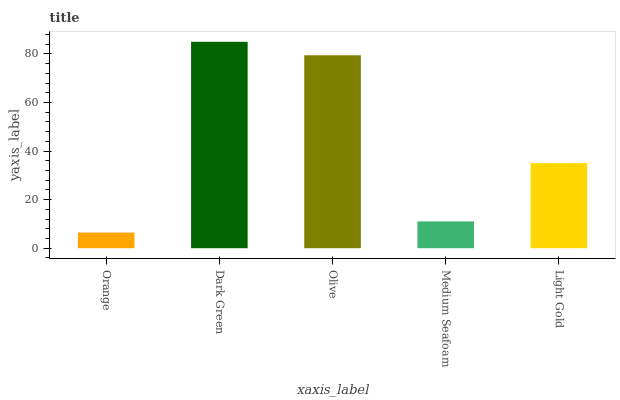Is Orange the minimum?
Answer yes or no. Yes. Is Dark Green the maximum?
Answer yes or no. Yes. Is Olive the minimum?
Answer yes or no. No. Is Olive the maximum?
Answer yes or no. No. Is Dark Green greater than Olive?
Answer yes or no. Yes. Is Olive less than Dark Green?
Answer yes or no. Yes. Is Olive greater than Dark Green?
Answer yes or no. No. Is Dark Green less than Olive?
Answer yes or no. No. Is Light Gold the high median?
Answer yes or no. Yes. Is Light Gold the low median?
Answer yes or no. Yes. Is Medium Seafoam the high median?
Answer yes or no. No. Is Orange the low median?
Answer yes or no. No. 